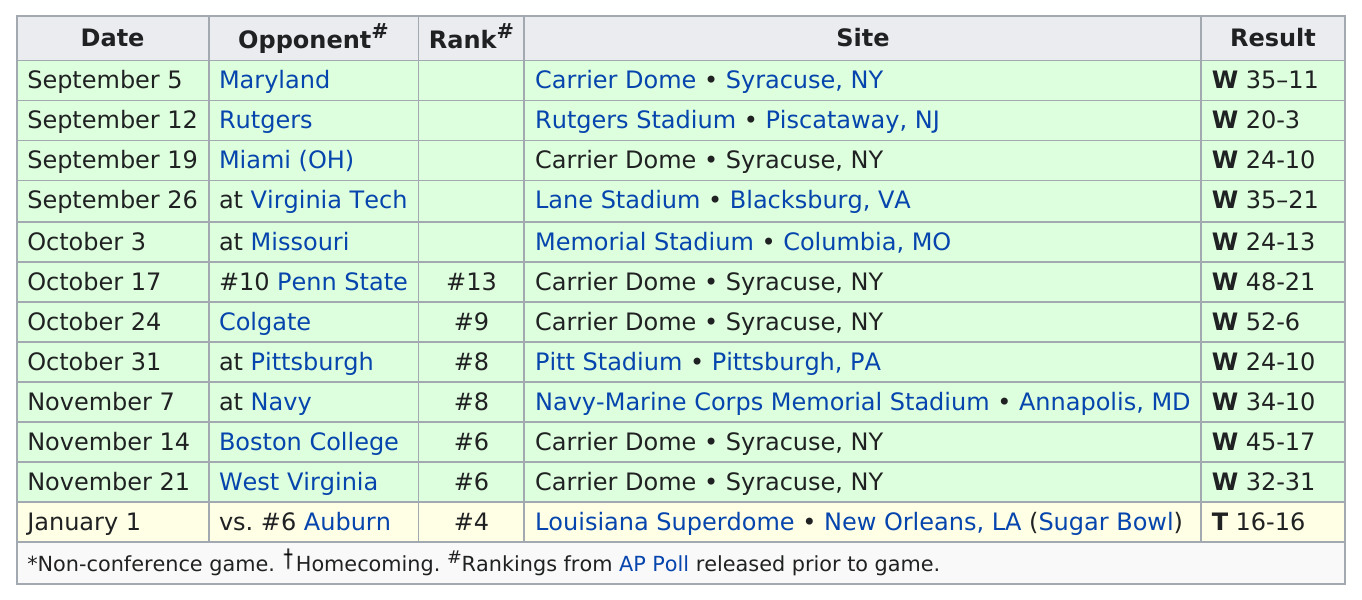Mention a couple of crucial points in this snapshot. The 1987 Syracuse Orangemen football team, on October 24th, at the Carrier Dome in Syracuse, New York, achieved their highest point total in a game against Colgate. The 1987 Syracuse Orange football team scored a victory with a win of 35 points during a game held at the Carrier Dome in Syracuse, New York on September 5th against the Maryland Terrapins. During a match against Virginia Tech, which took place just a few weeks later, they scored the same number of winning points as they did on September 5th. The second match occurred on September 26th. The 1987 Syracuse Orange football team played 12 games between September 5 and January 1, winning all but one of them. That one game ended in a tie against Auburn on a date that is not specified. The Syracuse Orangemen football team played four matches against rival colleges during the month of September, 1987. Rutgers' opponents scored the least amount of points against them in a game, demonstrating their strong defensive capabilities. 